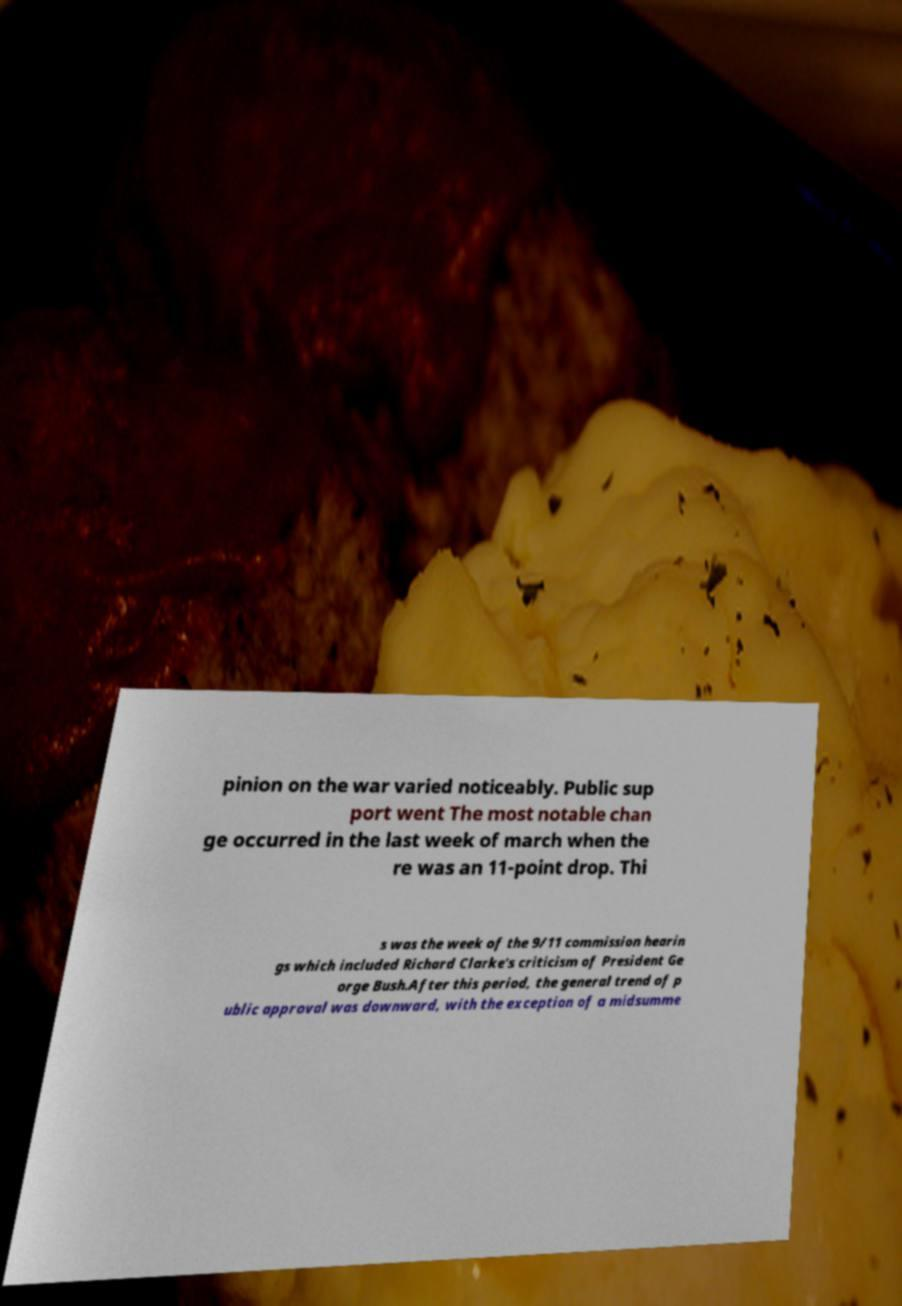Can you accurately transcribe the text from the provided image for me? pinion on the war varied noticeably. Public sup port went The most notable chan ge occurred in the last week of march when the re was an 11-point drop. Thi s was the week of the 9/11 commission hearin gs which included Richard Clarke's criticism of President Ge orge Bush.After this period, the general trend of p ublic approval was downward, with the exception of a midsumme 